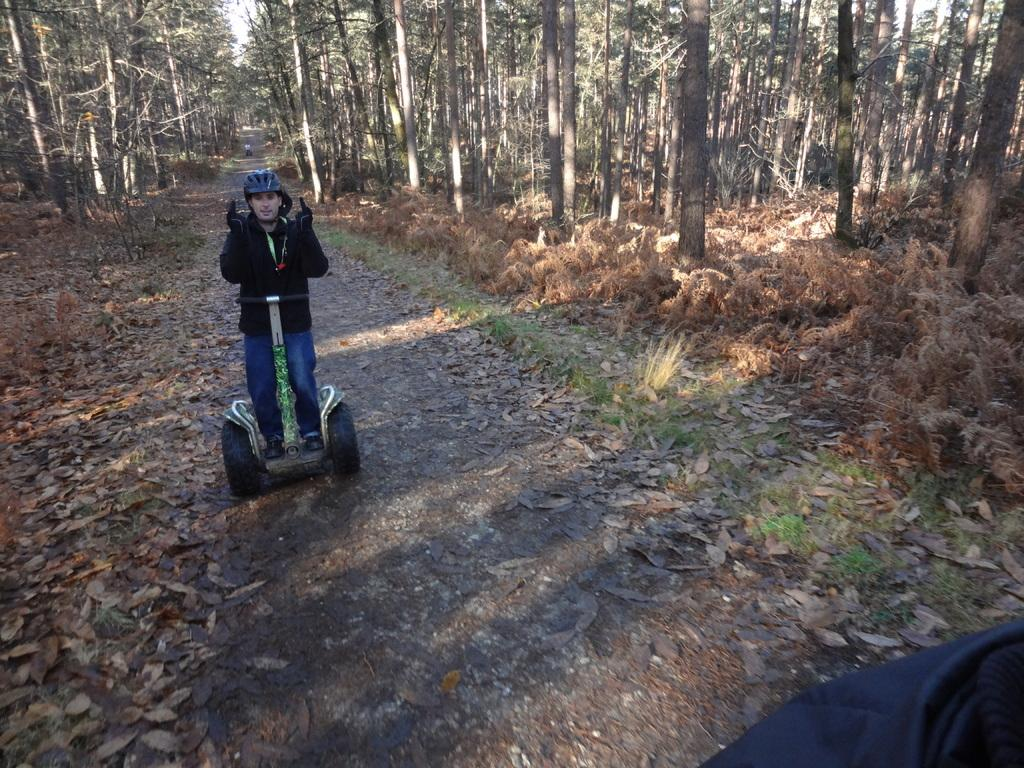Who is in the image? There is a man in the image. What is the man wearing? The man is wearing clothes, gloves, a helmet, and shoes. What is the man doing in the image? The man is on a skating scooter. What type of surface is the man on? There is a path in the image. What can be seen in the background of the image? Trees, grass, and dry leaves are visible in the image. What type of brush is the man using to apply the drug in the image? There is no brush or drug present in the image. The man is on a skating scooter and wearing protective gear. 